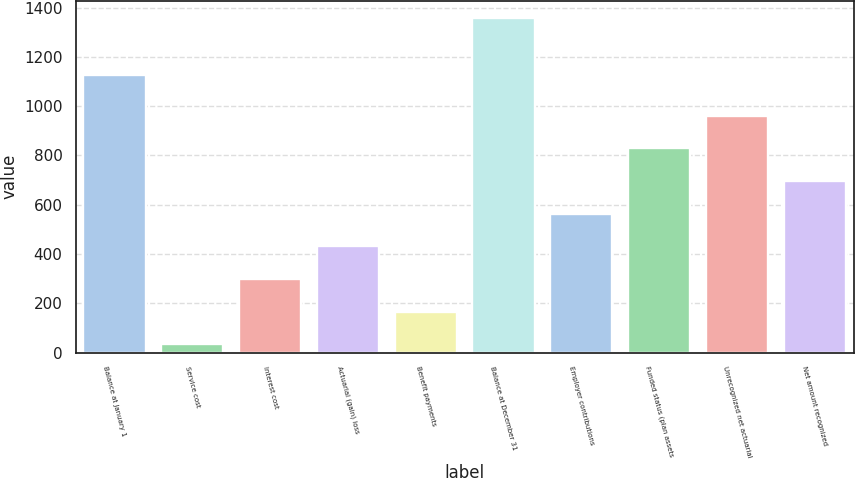<chart> <loc_0><loc_0><loc_500><loc_500><bar_chart><fcel>Balance at January 1<fcel>Service cost<fcel>Interest cost<fcel>Actuarial (gain) loss<fcel>Benefit payments<fcel>Balance at December 31<fcel>Employer contributions<fcel>Funded status (plan assets<fcel>Unrecognized net actuarial<fcel>Net amount recognized<nl><fcel>1125<fcel>34<fcel>299<fcel>431.5<fcel>166.5<fcel>1359<fcel>564<fcel>829<fcel>961.5<fcel>696.5<nl></chart> 